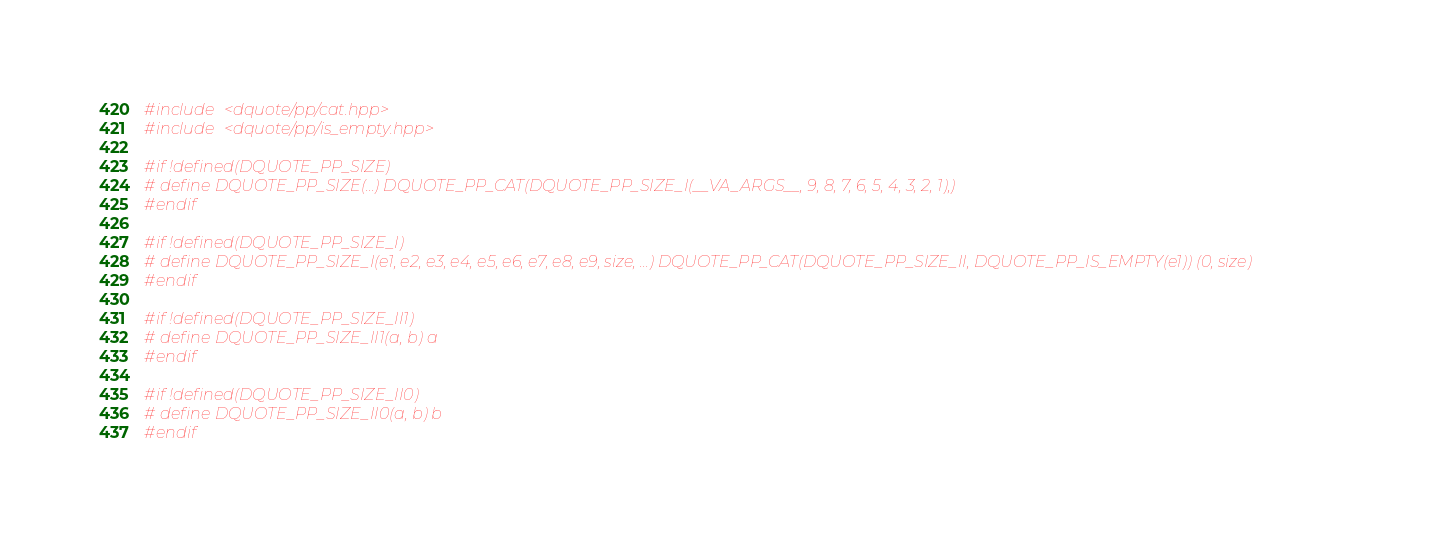Convert code to text. <code><loc_0><loc_0><loc_500><loc_500><_C++_>#include <dquote/pp/cat.hpp>
#include <dquote/pp/is_empty.hpp>

#if !defined(DQUOTE_PP_SIZE)
# define DQUOTE_PP_SIZE(...) DQUOTE_PP_CAT(DQUOTE_PP_SIZE_I(__VA_ARGS__, 9, 8, 7, 6, 5, 4, 3, 2, 1),)
#endif

#if !defined(DQUOTE_PP_SIZE_I)
# define DQUOTE_PP_SIZE_I(e1, e2, e3, e4, e5, e6, e7, e8, e9, size, ...) DQUOTE_PP_CAT(DQUOTE_PP_SIZE_II, DQUOTE_PP_IS_EMPTY(e1)) (0, size)
#endif

#if !defined(DQUOTE_PP_SIZE_II1)
# define DQUOTE_PP_SIZE_II1(a, b) a
#endif

#if !defined(DQUOTE_PP_SIZE_II0)
# define DQUOTE_PP_SIZE_II0(a, b) b
#endif
</code> 